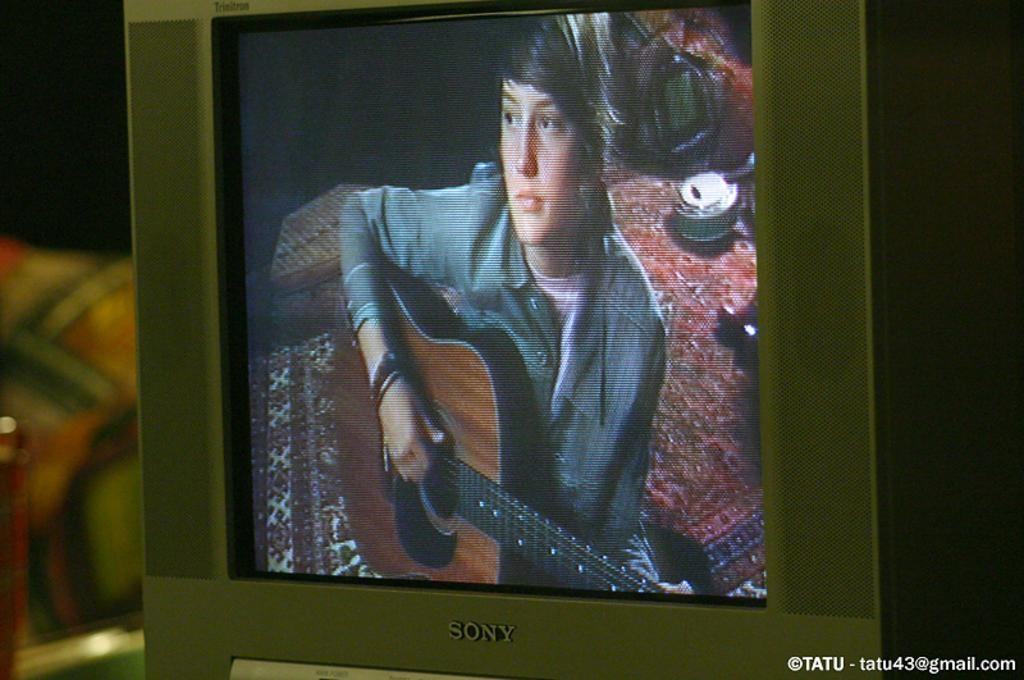<image>
Offer a succinct explanation of the picture presented. A sony television shows a person playing guitar on the screen. 